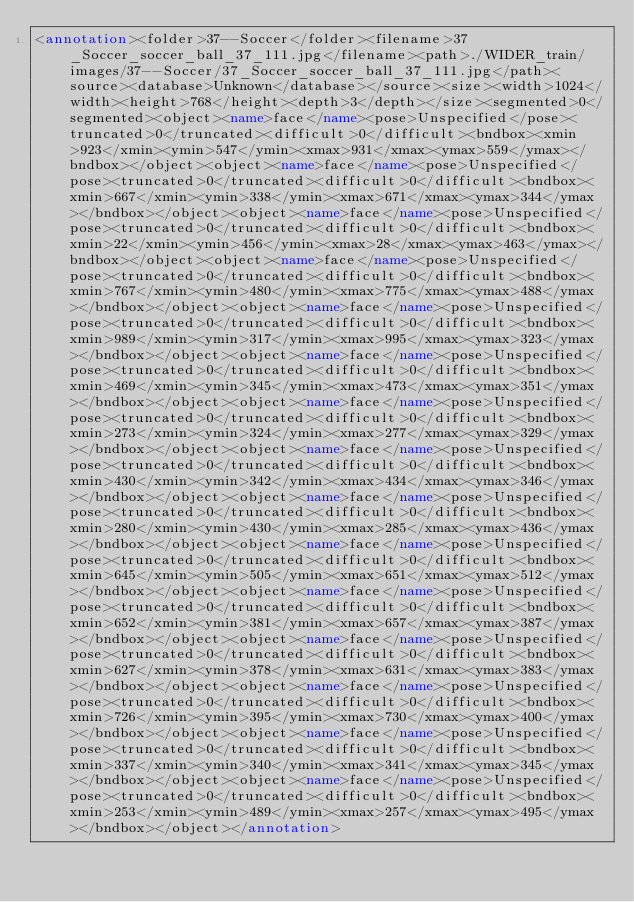Convert code to text. <code><loc_0><loc_0><loc_500><loc_500><_XML_><annotation><folder>37--Soccer</folder><filename>37_Soccer_soccer_ball_37_111.jpg</filename><path>./WIDER_train/images/37--Soccer/37_Soccer_soccer_ball_37_111.jpg</path><source><database>Unknown</database></source><size><width>1024</width><height>768</height><depth>3</depth></size><segmented>0</segmented><object><name>face</name><pose>Unspecified</pose><truncated>0</truncated><difficult>0</difficult><bndbox><xmin>923</xmin><ymin>547</ymin><xmax>931</xmax><ymax>559</ymax></bndbox></object><object><name>face</name><pose>Unspecified</pose><truncated>0</truncated><difficult>0</difficult><bndbox><xmin>667</xmin><ymin>338</ymin><xmax>671</xmax><ymax>344</ymax></bndbox></object><object><name>face</name><pose>Unspecified</pose><truncated>0</truncated><difficult>0</difficult><bndbox><xmin>22</xmin><ymin>456</ymin><xmax>28</xmax><ymax>463</ymax></bndbox></object><object><name>face</name><pose>Unspecified</pose><truncated>0</truncated><difficult>0</difficult><bndbox><xmin>767</xmin><ymin>480</ymin><xmax>775</xmax><ymax>488</ymax></bndbox></object><object><name>face</name><pose>Unspecified</pose><truncated>0</truncated><difficult>0</difficult><bndbox><xmin>989</xmin><ymin>317</ymin><xmax>995</xmax><ymax>323</ymax></bndbox></object><object><name>face</name><pose>Unspecified</pose><truncated>0</truncated><difficult>0</difficult><bndbox><xmin>469</xmin><ymin>345</ymin><xmax>473</xmax><ymax>351</ymax></bndbox></object><object><name>face</name><pose>Unspecified</pose><truncated>0</truncated><difficult>0</difficult><bndbox><xmin>273</xmin><ymin>324</ymin><xmax>277</xmax><ymax>329</ymax></bndbox></object><object><name>face</name><pose>Unspecified</pose><truncated>0</truncated><difficult>0</difficult><bndbox><xmin>430</xmin><ymin>342</ymin><xmax>434</xmax><ymax>346</ymax></bndbox></object><object><name>face</name><pose>Unspecified</pose><truncated>0</truncated><difficult>0</difficult><bndbox><xmin>280</xmin><ymin>430</ymin><xmax>285</xmax><ymax>436</ymax></bndbox></object><object><name>face</name><pose>Unspecified</pose><truncated>0</truncated><difficult>0</difficult><bndbox><xmin>645</xmin><ymin>505</ymin><xmax>651</xmax><ymax>512</ymax></bndbox></object><object><name>face</name><pose>Unspecified</pose><truncated>0</truncated><difficult>0</difficult><bndbox><xmin>652</xmin><ymin>381</ymin><xmax>657</xmax><ymax>387</ymax></bndbox></object><object><name>face</name><pose>Unspecified</pose><truncated>0</truncated><difficult>0</difficult><bndbox><xmin>627</xmin><ymin>378</ymin><xmax>631</xmax><ymax>383</ymax></bndbox></object><object><name>face</name><pose>Unspecified</pose><truncated>0</truncated><difficult>0</difficult><bndbox><xmin>726</xmin><ymin>395</ymin><xmax>730</xmax><ymax>400</ymax></bndbox></object><object><name>face</name><pose>Unspecified</pose><truncated>0</truncated><difficult>0</difficult><bndbox><xmin>337</xmin><ymin>340</ymin><xmax>341</xmax><ymax>345</ymax></bndbox></object><object><name>face</name><pose>Unspecified</pose><truncated>0</truncated><difficult>0</difficult><bndbox><xmin>253</xmin><ymin>489</ymin><xmax>257</xmax><ymax>495</ymax></bndbox></object></annotation></code> 